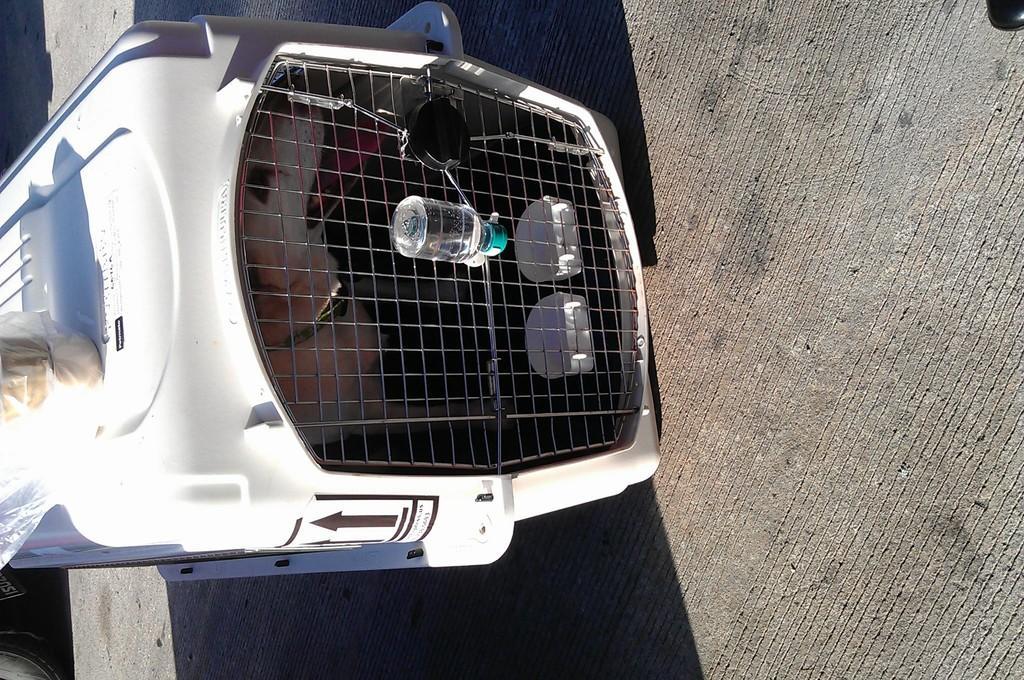Can you describe this image briefly? In this picture there is a dog in the cage, it seems to be dog cage and there is a water bottle on it. 